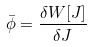Convert formula to latex. <formula><loc_0><loc_0><loc_500><loc_500>\bar { \phi } = \frac { \delta W [ J ] } { \delta J }</formula> 